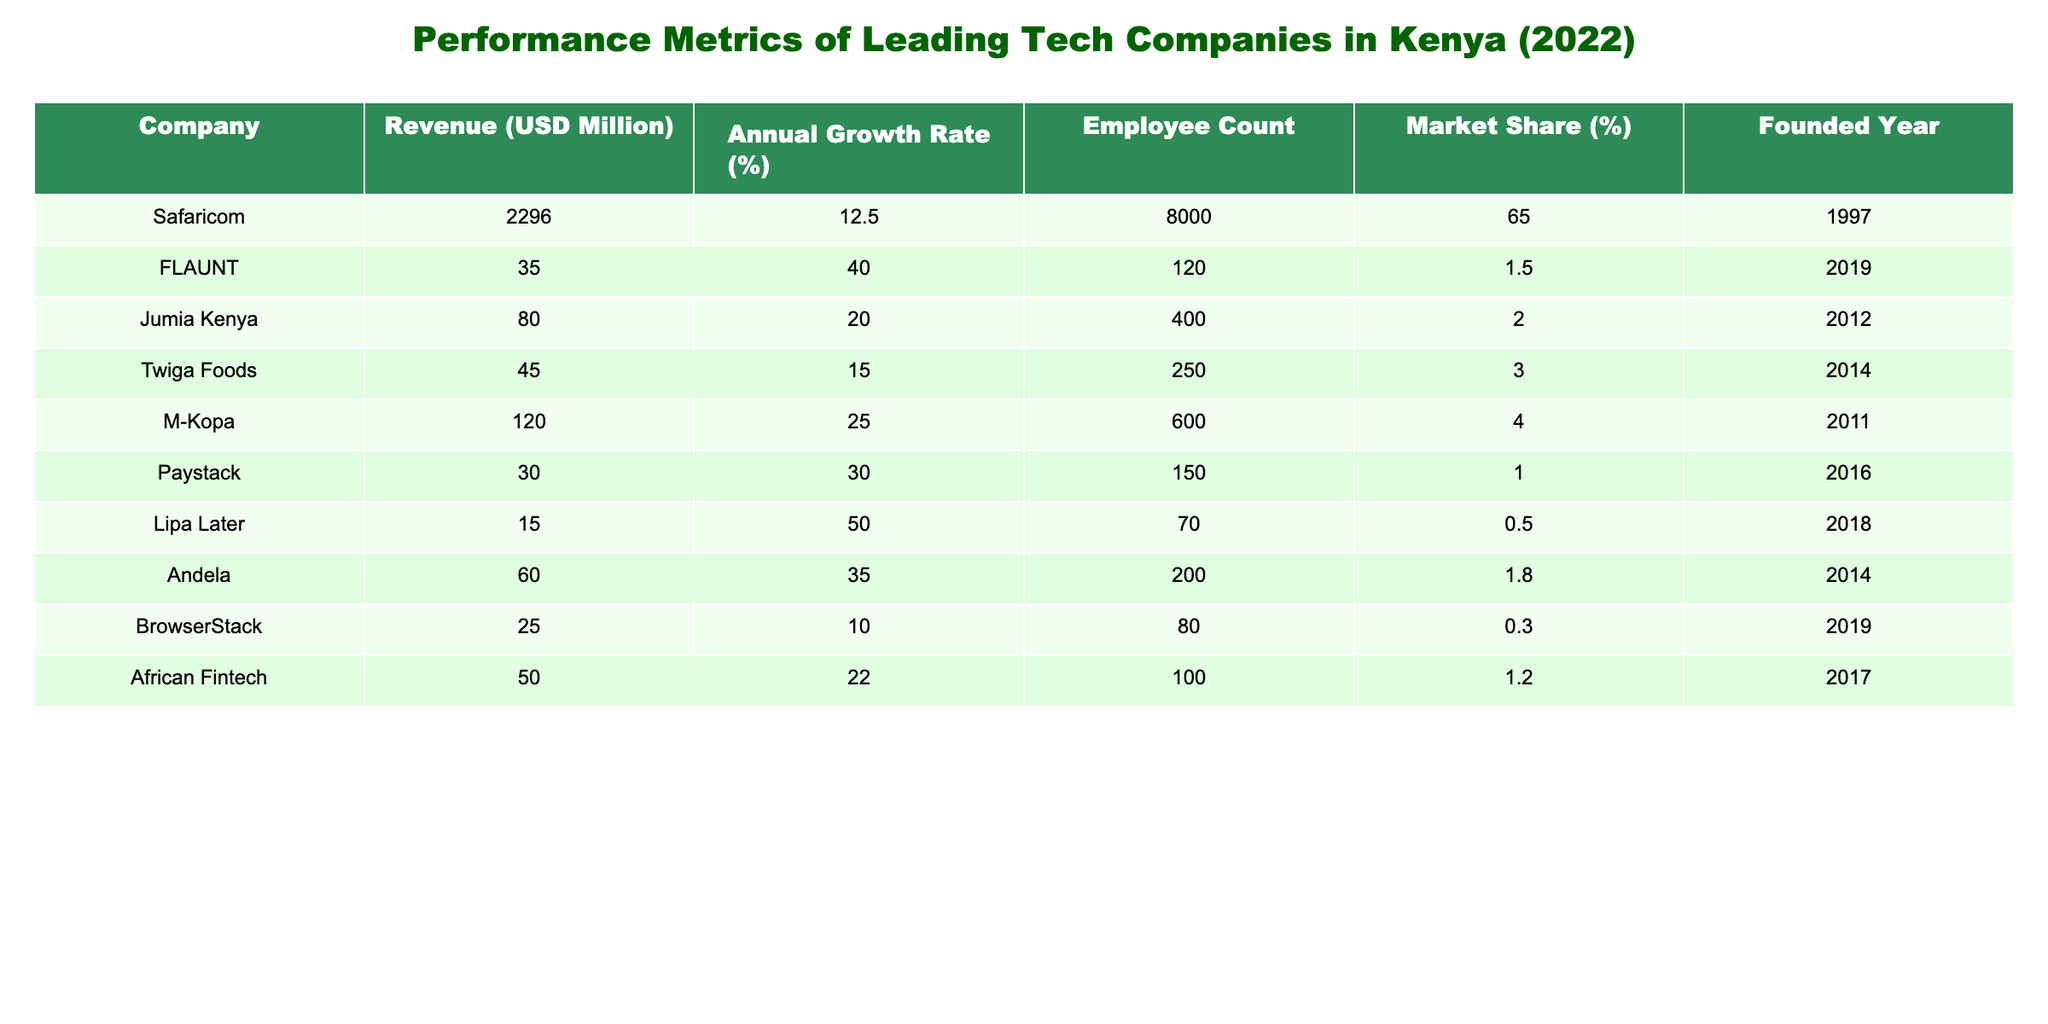What is the revenue of Safaricom? The table lists the revenue of each company. For Safaricom, the revenue is directly stated as 2296 million USD.
Answer: 2296 million USD Which company has the highest annual growth rate? By looking through the annual growth rates in the table, FLAUNT has the highest rate at 40.0%.
Answer: FLAUNT What is the total employee count for M-Kopa and Jumia Kenya? To find the total, we add the employee counts of both companies: M-Kopa has 600 employees and Jumia Kenya has 400 employees, so 600 + 400 = 1000.
Answer: 1000 Is Paystack more established than Safaricom based on the founded year? Safaricom was founded in 1997, while Paystack was founded in 2016. Since 1997 is earlier than 2016, Paystack is less established than Safaricom.
Answer: No What is the average market share of the tech companies listed in the table? To calculate the average market share, we add the market shares of all companies: 65 + 1.5 + 2 + 3 + 4 + 1 + 0.5 + 1.8 + 0.3 + 1.2 = 80.3. There are 10 companies, so the average is 80.3 / 10 = 8.03.
Answer: 8.03 Which company has the smallest market share, and what is the value? Looking through the market share percentages in the table, Lipa Later has the smallest market share at 0.5%.
Answer: Lipa Later, 0.5% What is the difference in revenue between Safaricom and the company with the lowest revenue? The lowest revenue is that of Lipa Later, which is 15 million USD. To find the difference: 2296 (Safaricom) - 15 (Lipa Later) = 2281 million USD.
Answer: 2281 million USD How many companies have an employee count of over 200? By checking the employee counts, we find that Safaricom (8000), Jumia Kenya (400), M-Kopa (600), Twiga Foods (250), and Andela (200) all have counts over 200. There are 5 such companies.
Answer: 5 